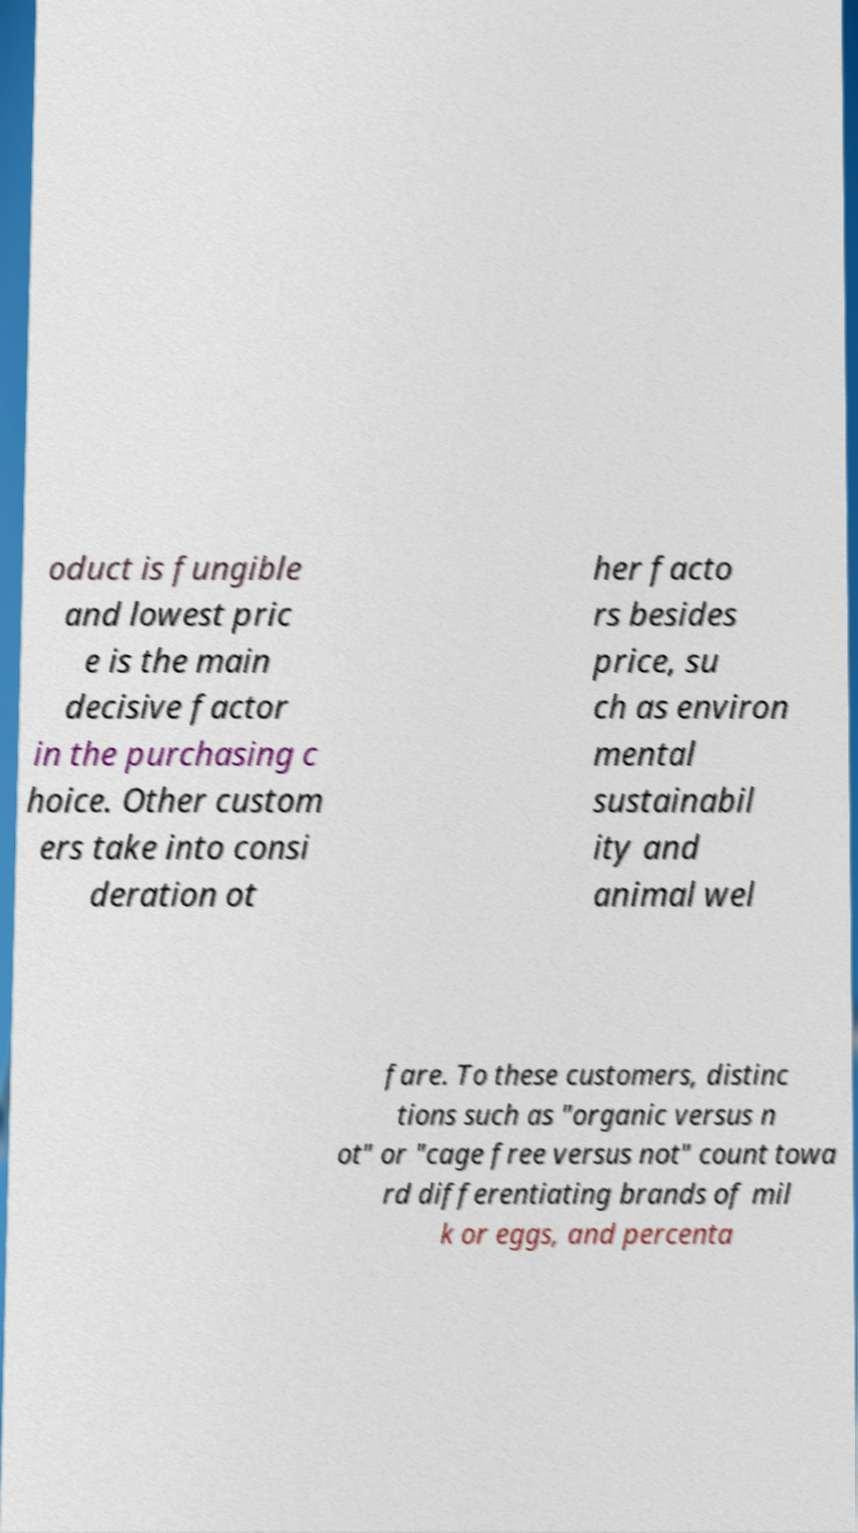Could you extract and type out the text from this image? oduct is fungible and lowest pric e is the main decisive factor in the purchasing c hoice. Other custom ers take into consi deration ot her facto rs besides price, su ch as environ mental sustainabil ity and animal wel fare. To these customers, distinc tions such as "organic versus n ot" or "cage free versus not" count towa rd differentiating brands of mil k or eggs, and percenta 